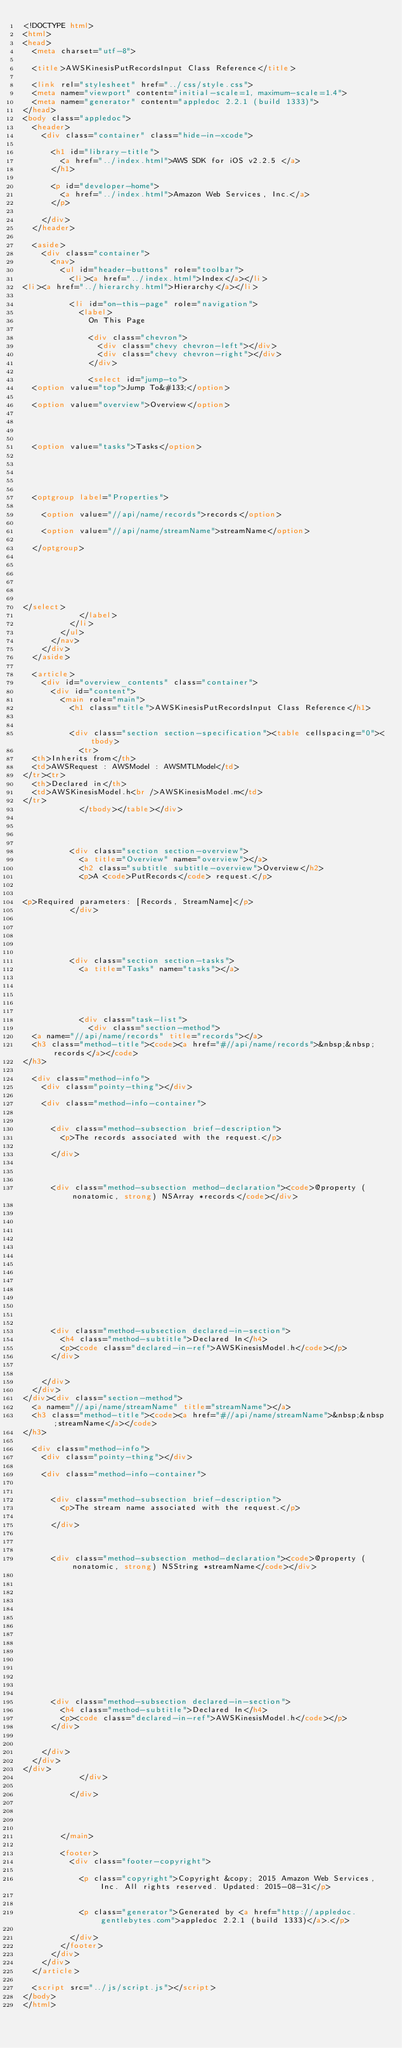<code> <loc_0><loc_0><loc_500><loc_500><_HTML_><!DOCTYPE html>
<html>
<head>
	<meta charset="utf-8">

	<title>AWSKinesisPutRecordsInput Class Reference</title>

	<link rel="stylesheet" href="../css/style.css">
	<meta name="viewport" content="initial-scale=1, maximum-scale=1.4">
	<meta name="generator" content="appledoc 2.2.1 (build 1333)">
</head>
<body class="appledoc">
	<header>
		<div class="container" class="hide-in-xcode">
			
			<h1 id="library-title">
				<a href="../index.html">AWS SDK for iOS v2.2.5 </a>
			</h1>

			<p id="developer-home">
				<a href="../index.html">Amazon Web Services, Inc.</a>
			</p>
			
		</div>
	</header>

	<aside>
		<div class="container">
			<nav>
				<ul id="header-buttons" role="toolbar">
					<li><a href="../index.html">Index</a></li>
<li><a href="../hierarchy.html">Hierarchy</a></li>

					<li id="on-this-page" role="navigation">
						<label>
							On This Page

							<div class="chevron">
								<div class="chevy chevron-left"></div>
								<div class="chevy chevron-right"></div>
							</div>

							<select id="jump-to">
	<option value="top">Jump To&#133;</option>
	
	<option value="overview">Overview</option>
	

	
	
	<option value="tasks">Tasks</option>
	
	

	
	
	<optgroup label="Properties">
		
		<option value="//api/name/records">records</option>
		
		<option value="//api/name/streamName">streamName</option>
		
	</optgroup>
	

	

	
	
</select>
						</label>
					</li>
				</ul>
			</nav>
		</div>
	</aside>

	<article>
		<div id="overview_contents" class="container">
			<div id="content">
				<main role="main">
					<h1 class="title">AWSKinesisPutRecordsInput Class Reference</h1>

					
					<div class="section section-specification"><table cellspacing="0"><tbody>
						<tr>
	<th>Inherits from</th>
	<td>AWSRequest : AWSModel : AWSMTLModel</td>
</tr><tr>
	<th>Declared in</th>
	<td>AWSKinesisModel.h<br />AWSKinesisModel.m</td>
</tr>
						</tbody></table></div>
					

                    
					
					<div class="section section-overview">
						<a title="Overview" name="overview"></a>
						<h2 class="subtitle subtitle-overview">Overview</h2>
						<p>A <code>PutRecords</code> request.</p>


<p>Required parameters: [Records, StreamName]</p>
					</div>
					
					

					
					
					<div class="section section-tasks">
						<a title="Tasks" name="tasks"></a>
						

						
						

						<div class="task-list">
							<div class="section-method">
	<a name="//api/name/records" title="records"></a>
	<h3 class="method-title"><code><a href="#//api/name/records">&nbsp;&nbsp;records</a></code>
</h3>

	<div class="method-info">
		<div class="pointy-thing"></div>

		<div class="method-info-container">
			
			
			<div class="method-subsection brief-description">
				<p>The records associated with the request.</p>

			</div>
			
		    

			<div class="method-subsection method-declaration"><code>@property (nonatomic, strong) NSArray *records</code></div>

		    
			

			

			

			

			

			

			
			<div class="method-subsection declared-in-section">
				<h4 class="method-subtitle">Declared In</h4>
				<p><code class="declared-in-ref">AWSKinesisModel.h</code></p>
			</div>
			
			
		</div>
	</div>
</div><div class="section-method">
	<a name="//api/name/streamName" title="streamName"></a>
	<h3 class="method-title"><code><a href="#//api/name/streamName">&nbsp;&nbsp;streamName</a></code>
</h3>

	<div class="method-info">
		<div class="pointy-thing"></div>

		<div class="method-info-container">
			
			
			<div class="method-subsection brief-description">
				<p>The stream name associated with the request.</p>

			</div>
			
		    

			<div class="method-subsection method-declaration"><code>@property (nonatomic, strong) NSString *streamName</code></div>

		    
			

			

			

			

			

			

			
			<div class="method-subsection declared-in-section">
				<h4 class="method-subtitle">Declared In</h4>
				<p><code class="declared-in-ref">AWSKinesisModel.h</code></p>
			</div>
			
			
		</div>
	</div>
</div>
						</div>
						
					</div>
					
					

                    
				</main>

				<footer>
					<div class="footer-copyright">
						
						<p class="copyright">Copyright &copy; 2015 Amazon Web Services, Inc. All rights reserved. Updated: 2015-08-31</p>
						
						
						<p class="generator">Generated by <a href="http://appledoc.gentlebytes.com">appledoc 2.2.1 (build 1333)</a>.</p>
						
					</div>
				</footer>
			</div>
		</div>
	</article>

	<script src="../js/script.js"></script>
</body>
</html></code> 